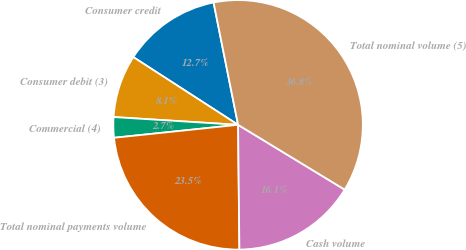<chart> <loc_0><loc_0><loc_500><loc_500><pie_chart><fcel>Consumer credit<fcel>Consumer debit (3)<fcel>Commercial (4)<fcel>Total nominal payments volume<fcel>Cash volume<fcel>Total nominal volume (5)<nl><fcel>12.72%<fcel>8.14%<fcel>2.65%<fcel>23.51%<fcel>16.14%<fcel>36.84%<nl></chart> 